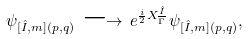Convert formula to latex. <formula><loc_0><loc_0><loc_500><loc_500>\psi _ { [ \hat { I } , m ] ( p , q ) } \, \longrightarrow \, e ^ { \frac { i } { 2 } X _ { \overline { \Gamma } } ^ { \hat { I } } } \, \psi _ { [ \hat { I } , m ] ( p , q ) } ,</formula> 